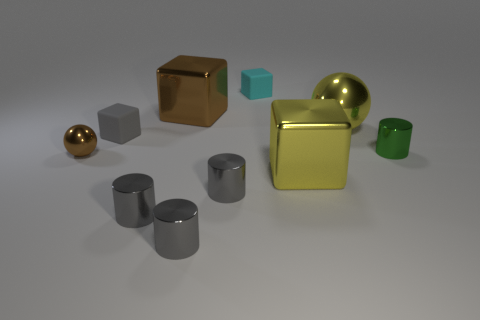Subtract all brown balls. How many gray cylinders are left? 3 Subtract 1 cylinders. How many cylinders are left? 3 Subtract all blocks. How many objects are left? 6 Add 7 large yellow metal things. How many large yellow metal things are left? 9 Add 1 large brown balls. How many large brown balls exist? 1 Subtract 1 gray cubes. How many objects are left? 9 Subtract all tiny cyan blocks. Subtract all large brown shiny blocks. How many objects are left? 8 